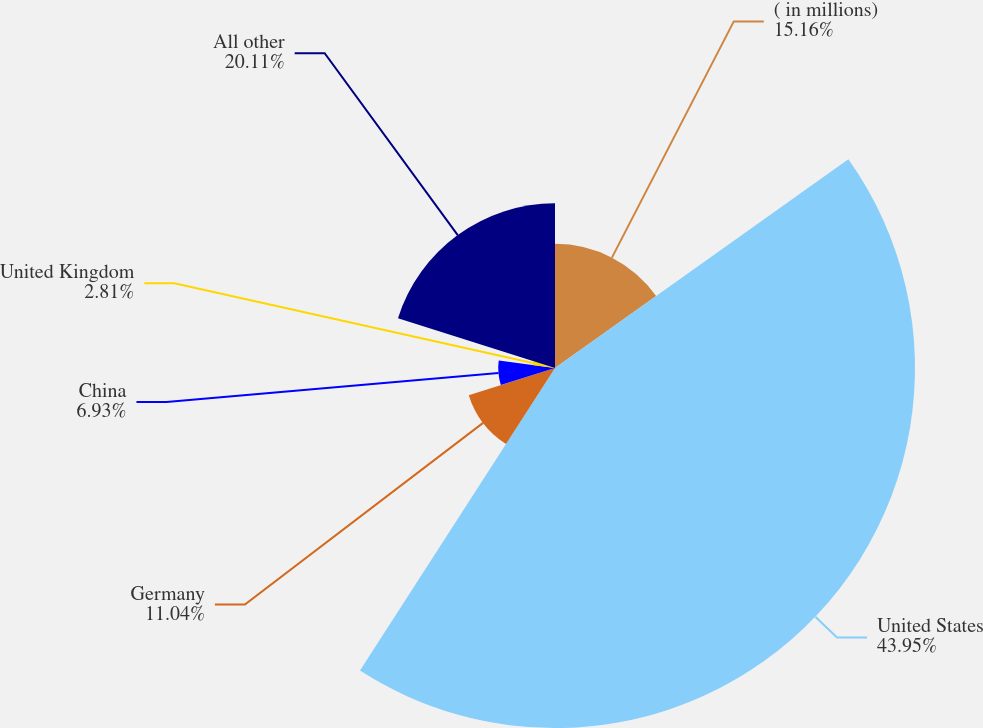Convert chart to OTSL. <chart><loc_0><loc_0><loc_500><loc_500><pie_chart><fcel>( in millions)<fcel>United States<fcel>Germany<fcel>China<fcel>United Kingdom<fcel>All other<nl><fcel>15.16%<fcel>43.95%<fcel>11.04%<fcel>6.93%<fcel>2.81%<fcel>20.11%<nl></chart> 